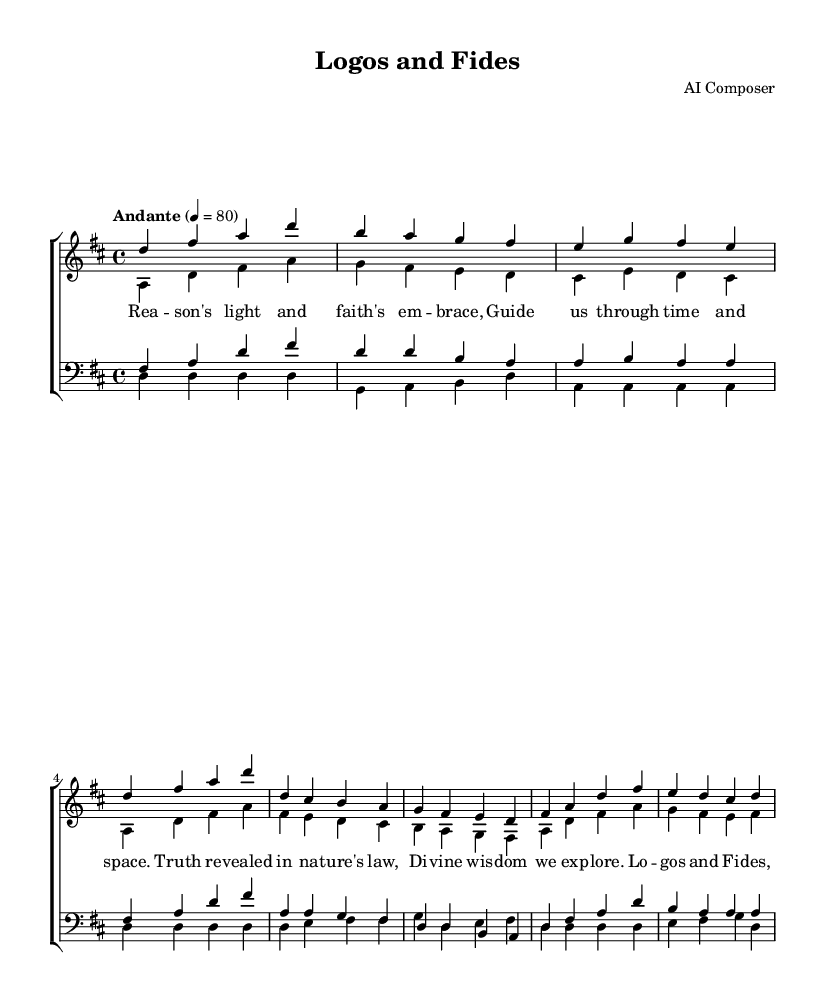What is the key signature of this music? The key signature is indicated at the beginning of the piece and shows two sharps, which corresponds to D major.
Answer: D major What is the time signature of this piece? The time signature is found at the beginning after the key signature, where it shows four beats per measure, signified as 4/4.
Answer: 4/4 What tempo marking is indicated for this piece? The tempo is specified just below the time signature, where it is noted as "Andante" with a metronome mark of 80 beats per minute.
Answer: Andante, 80 How many measures are in the verse section? By counting the measures in the soprano, alto, tenor, and bass verse sections, we can see that there are four measures in each voice part, leading to a total of twelve measures combined.
Answer: Twelve Which vocal parts sing the chorus? The chorus is sung by sopranos, altos, tenors, and basses, as indicated by the staff headings.
Answer: Sopranos, altos, tenors, and basses What are the first two words of the chorus? The lyrics for the chorus begin immediately below the staff for the sopranos, and the first two words read as "Logos and."
Answer: Logos and What thematic elements are represented in the lyrics of this hymn? The lyrics explore themes of faith and reason, illustrating a harmony between divine wisdom and human understanding as reflected in the titles and the words.
Answer: Faith and reason 